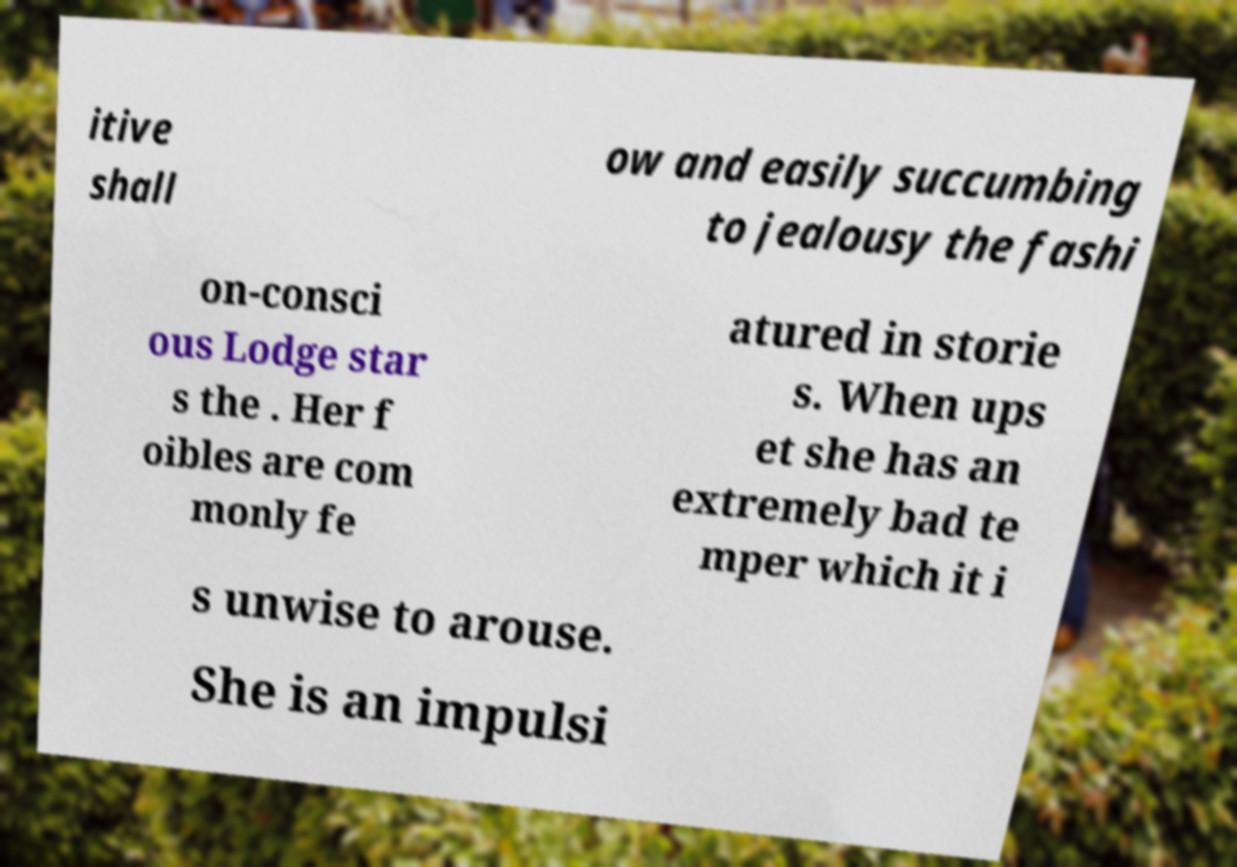Could you extract and type out the text from this image? itive shall ow and easily succumbing to jealousy the fashi on-consci ous Lodge star s the . Her f oibles are com monly fe atured in storie s. When ups et she has an extremely bad te mper which it i s unwise to arouse. She is an impulsi 